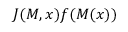<formula> <loc_0><loc_0><loc_500><loc_500>J ( M , x ) f ( M ( x ) )</formula> 